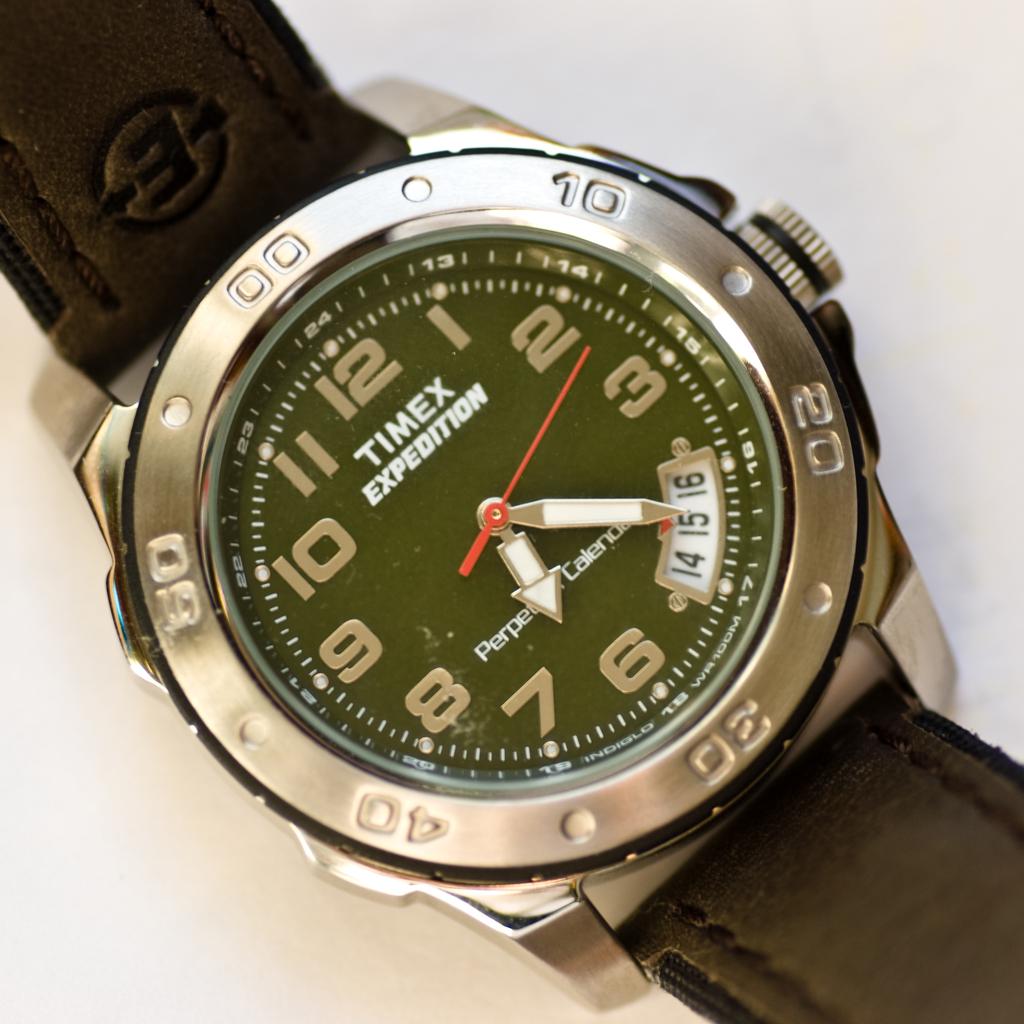What is the edition of the timex watch?
Provide a succinct answer. Expedition. What brand is the watch?
Offer a terse response. Timex. 